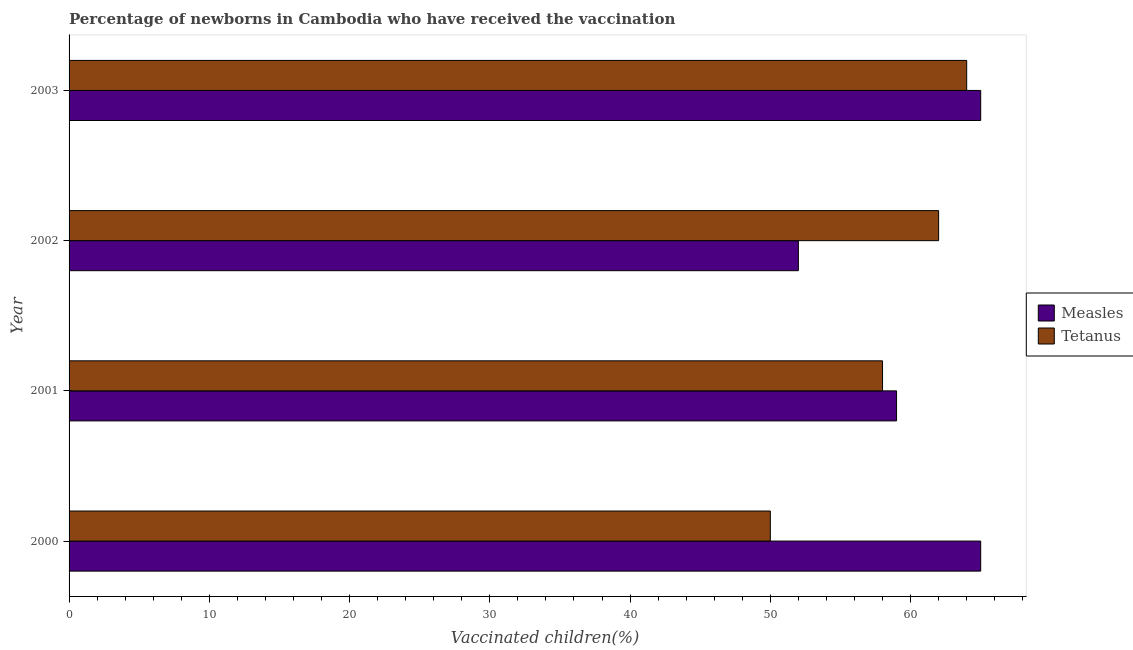How many groups of bars are there?
Your response must be concise. 4. Are the number of bars per tick equal to the number of legend labels?
Offer a very short reply. Yes. How many bars are there on the 4th tick from the top?
Your answer should be very brief. 2. How many bars are there on the 4th tick from the bottom?
Keep it short and to the point. 2. What is the label of the 4th group of bars from the top?
Make the answer very short. 2000. In how many cases, is the number of bars for a given year not equal to the number of legend labels?
Offer a very short reply. 0. What is the percentage of newborns who received vaccination for tetanus in 2000?
Give a very brief answer. 50. Across all years, what is the maximum percentage of newborns who received vaccination for measles?
Your answer should be compact. 65. Across all years, what is the minimum percentage of newborns who received vaccination for measles?
Provide a short and direct response. 52. In which year was the percentage of newborns who received vaccination for measles minimum?
Keep it short and to the point. 2002. What is the total percentage of newborns who received vaccination for tetanus in the graph?
Your response must be concise. 234. What is the difference between the percentage of newborns who received vaccination for measles in 2000 and that in 2003?
Your response must be concise. 0. What is the difference between the percentage of newborns who received vaccination for measles in 2002 and the percentage of newborns who received vaccination for tetanus in 2003?
Your answer should be very brief. -12. What is the average percentage of newborns who received vaccination for measles per year?
Offer a very short reply. 60.25. In the year 2003, what is the difference between the percentage of newborns who received vaccination for measles and percentage of newborns who received vaccination for tetanus?
Ensure brevity in your answer.  1. What is the ratio of the percentage of newborns who received vaccination for tetanus in 2000 to that in 2001?
Ensure brevity in your answer.  0.86. What is the difference between the highest and the second highest percentage of newborns who received vaccination for tetanus?
Provide a short and direct response. 2. What is the difference between the highest and the lowest percentage of newborns who received vaccination for tetanus?
Give a very brief answer. 14. What does the 1st bar from the top in 2003 represents?
Provide a short and direct response. Tetanus. What does the 2nd bar from the bottom in 2000 represents?
Your answer should be compact. Tetanus. How many bars are there?
Your response must be concise. 8. Are all the bars in the graph horizontal?
Your answer should be compact. Yes. How many years are there in the graph?
Your answer should be very brief. 4. Does the graph contain any zero values?
Provide a short and direct response. No. Does the graph contain grids?
Provide a short and direct response. No. Where does the legend appear in the graph?
Give a very brief answer. Center right. How are the legend labels stacked?
Make the answer very short. Vertical. What is the title of the graph?
Your response must be concise. Percentage of newborns in Cambodia who have received the vaccination. Does "Goods" appear as one of the legend labels in the graph?
Offer a very short reply. No. What is the label or title of the X-axis?
Your answer should be compact. Vaccinated children(%)
. What is the label or title of the Y-axis?
Your answer should be compact. Year. What is the Vaccinated children(%)
 of Tetanus in 2000?
Make the answer very short. 50. What is the Vaccinated children(%)
 of Tetanus in 2001?
Keep it short and to the point. 58. What is the Vaccinated children(%)
 of Measles in 2003?
Make the answer very short. 65. What is the Vaccinated children(%)
 in Tetanus in 2003?
Provide a short and direct response. 64. Across all years, what is the maximum Vaccinated children(%)
 of Tetanus?
Ensure brevity in your answer.  64. Across all years, what is the minimum Vaccinated children(%)
 of Measles?
Your answer should be compact. 52. What is the total Vaccinated children(%)
 in Measles in the graph?
Make the answer very short. 241. What is the total Vaccinated children(%)
 of Tetanus in the graph?
Your answer should be compact. 234. What is the difference between the Vaccinated children(%)
 in Measles in 2000 and that in 2002?
Your answer should be very brief. 13. What is the difference between the Vaccinated children(%)
 of Measles in 2000 and that in 2003?
Ensure brevity in your answer.  0. What is the difference between the Vaccinated children(%)
 of Tetanus in 2001 and that in 2003?
Offer a terse response. -6. What is the difference between the Vaccinated children(%)
 in Measles in 2002 and that in 2003?
Provide a short and direct response. -13. What is the difference between the Vaccinated children(%)
 of Measles in 2000 and the Vaccinated children(%)
 of Tetanus in 2002?
Give a very brief answer. 3. What is the difference between the Vaccinated children(%)
 in Measles in 2000 and the Vaccinated children(%)
 in Tetanus in 2003?
Ensure brevity in your answer.  1. What is the difference between the Vaccinated children(%)
 in Measles in 2002 and the Vaccinated children(%)
 in Tetanus in 2003?
Provide a succinct answer. -12. What is the average Vaccinated children(%)
 in Measles per year?
Keep it short and to the point. 60.25. What is the average Vaccinated children(%)
 in Tetanus per year?
Provide a short and direct response. 58.5. In the year 2000, what is the difference between the Vaccinated children(%)
 of Measles and Vaccinated children(%)
 of Tetanus?
Keep it short and to the point. 15. In the year 2001, what is the difference between the Vaccinated children(%)
 in Measles and Vaccinated children(%)
 in Tetanus?
Ensure brevity in your answer.  1. In the year 2003, what is the difference between the Vaccinated children(%)
 in Measles and Vaccinated children(%)
 in Tetanus?
Offer a very short reply. 1. What is the ratio of the Vaccinated children(%)
 of Measles in 2000 to that in 2001?
Provide a short and direct response. 1.1. What is the ratio of the Vaccinated children(%)
 in Tetanus in 2000 to that in 2001?
Provide a succinct answer. 0.86. What is the ratio of the Vaccinated children(%)
 of Measles in 2000 to that in 2002?
Your response must be concise. 1.25. What is the ratio of the Vaccinated children(%)
 in Tetanus in 2000 to that in 2002?
Give a very brief answer. 0.81. What is the ratio of the Vaccinated children(%)
 in Tetanus in 2000 to that in 2003?
Keep it short and to the point. 0.78. What is the ratio of the Vaccinated children(%)
 of Measles in 2001 to that in 2002?
Provide a succinct answer. 1.13. What is the ratio of the Vaccinated children(%)
 of Tetanus in 2001 to that in 2002?
Ensure brevity in your answer.  0.94. What is the ratio of the Vaccinated children(%)
 in Measles in 2001 to that in 2003?
Your answer should be compact. 0.91. What is the ratio of the Vaccinated children(%)
 of Tetanus in 2001 to that in 2003?
Provide a succinct answer. 0.91. What is the ratio of the Vaccinated children(%)
 in Tetanus in 2002 to that in 2003?
Offer a very short reply. 0.97. What is the difference between the highest and the second highest Vaccinated children(%)
 in Measles?
Offer a terse response. 0. 